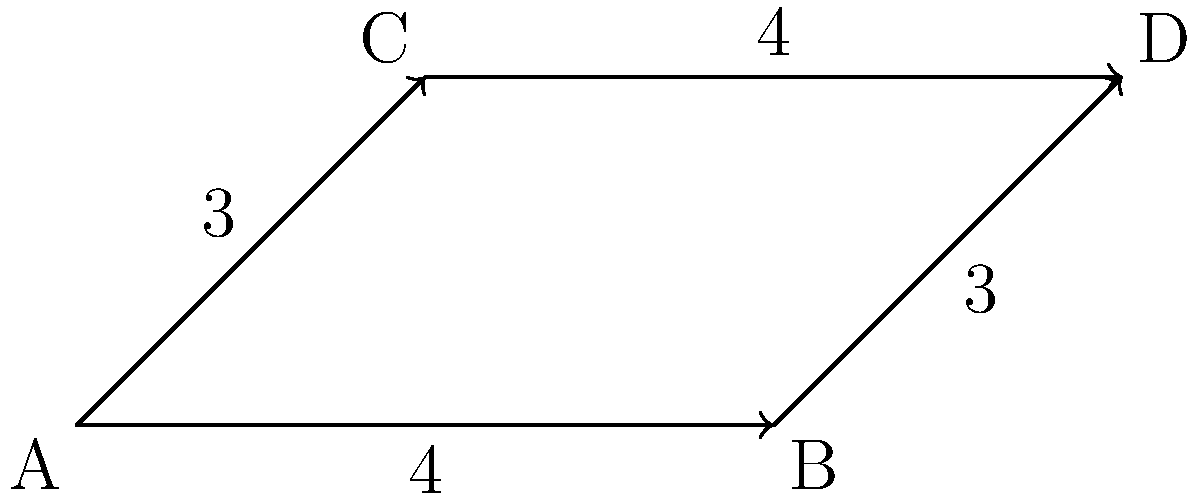In the directed graph representing code dependencies, where vertices represent modules and edge weights represent the number of shared functions, which pair of edges forms congruent line segments? Explain the significance of this congruence in terms of code modularity and best practices. To solve this problem, we need to follow these steps:

1. Identify the line segments in the graph:
   - $\overline{AB}$ with weight 4
   - $\overline{AC}$ with weight 3
   - $\overline{BD}$ with weight 3
   - $\overline{CD}$ with weight 4

2. Recall the definition of congruent line segments: two line segments are congruent if they have the same length.

3. In this context, the weight of an edge represents the number of shared functions between modules, which we can interpret as the "length" of the dependency.

4. Compare the weights of the edges:
   - $\overline{AB}$ and $\overline{CD}$ both have weight 4
   - $\overline{AC}$ and $\overline{BD}$ both have weight 3

5. Therefore, $\overline{AB} \cong \overline{CD}$ and $\overline{AC} \cong \overline{BD}$

6. The significance of this congruence in terms of code modularity and best practices:
   - Congruent edges indicate similar levels of coupling between different pairs of modules.
   - $\overline{AB} \cong \overline{CD}$ suggests that the dependency between modules A and B is similar in strength to the dependency between C and D.
   - This balanced structure can be beneficial for maintainability and scalability of the codebase.
   - It may indicate a well-designed system where dependencies are distributed evenly, reducing the risk of having overly coupled components.
   - However, it's important to note that while balanced dependencies can be advantageous, the absolute number of shared functions (4 in this case) might still be considered high, depending on the specific context and design goals of the system.

7. As a best practice, we should aim for loose coupling and high cohesion. The congruence observed here might be a result of carefully designed interfaces between modules, ensuring that dependencies are consistent and manageable across the system.
Answer: $\overline{AB} \cong \overline{CD}$ and $\overline{AC} \cong \overline{BD}$, indicating balanced dependencies that may reflect good modular design practices. 